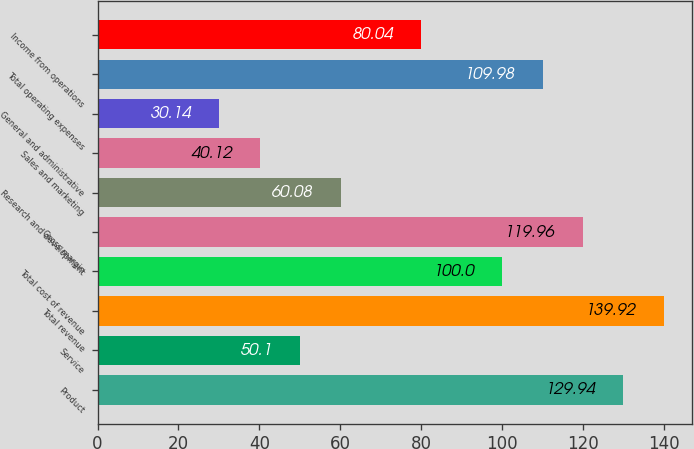Convert chart to OTSL. <chart><loc_0><loc_0><loc_500><loc_500><bar_chart><fcel>Product<fcel>Service<fcel>Total revenue<fcel>Total cost of revenue<fcel>Gross margin<fcel>Research and development<fcel>Sales and marketing<fcel>General and administrative<fcel>Total operating expenses<fcel>Income from operations<nl><fcel>129.94<fcel>50.1<fcel>139.92<fcel>100<fcel>119.96<fcel>60.08<fcel>40.12<fcel>30.14<fcel>109.98<fcel>80.04<nl></chart> 